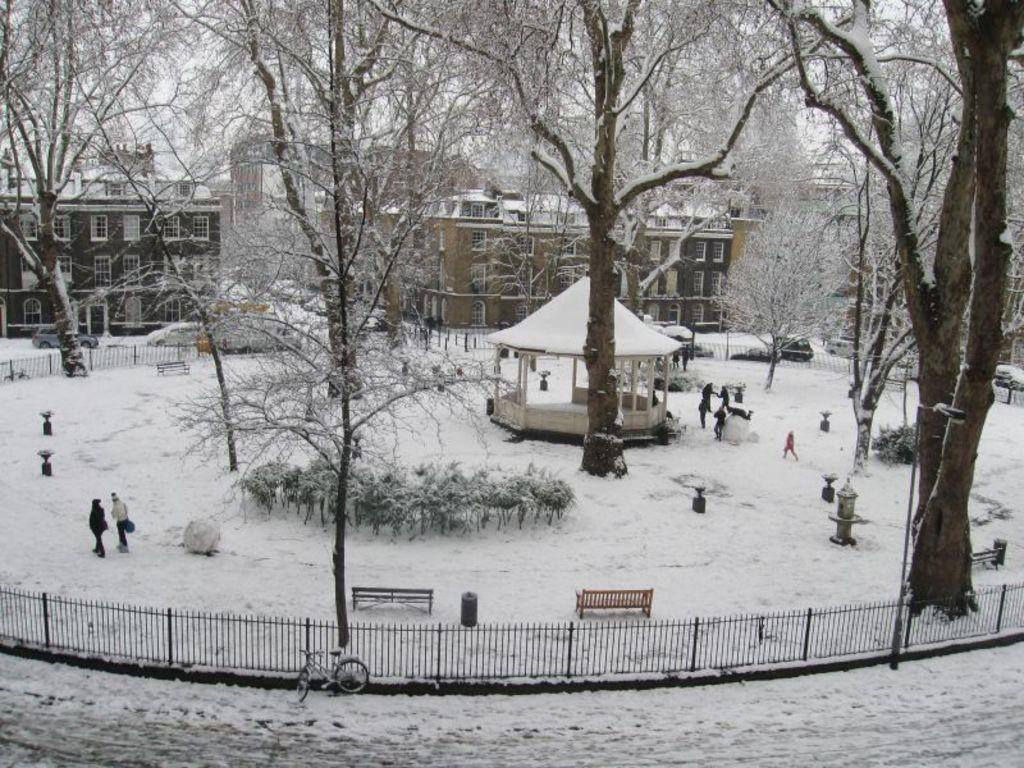How would you summarize this image in a sentence or two? In this image I can see fence, snow, a bicycle, benches, people and some other objects. In the background I can see buildings, trees, plants and the sky. 